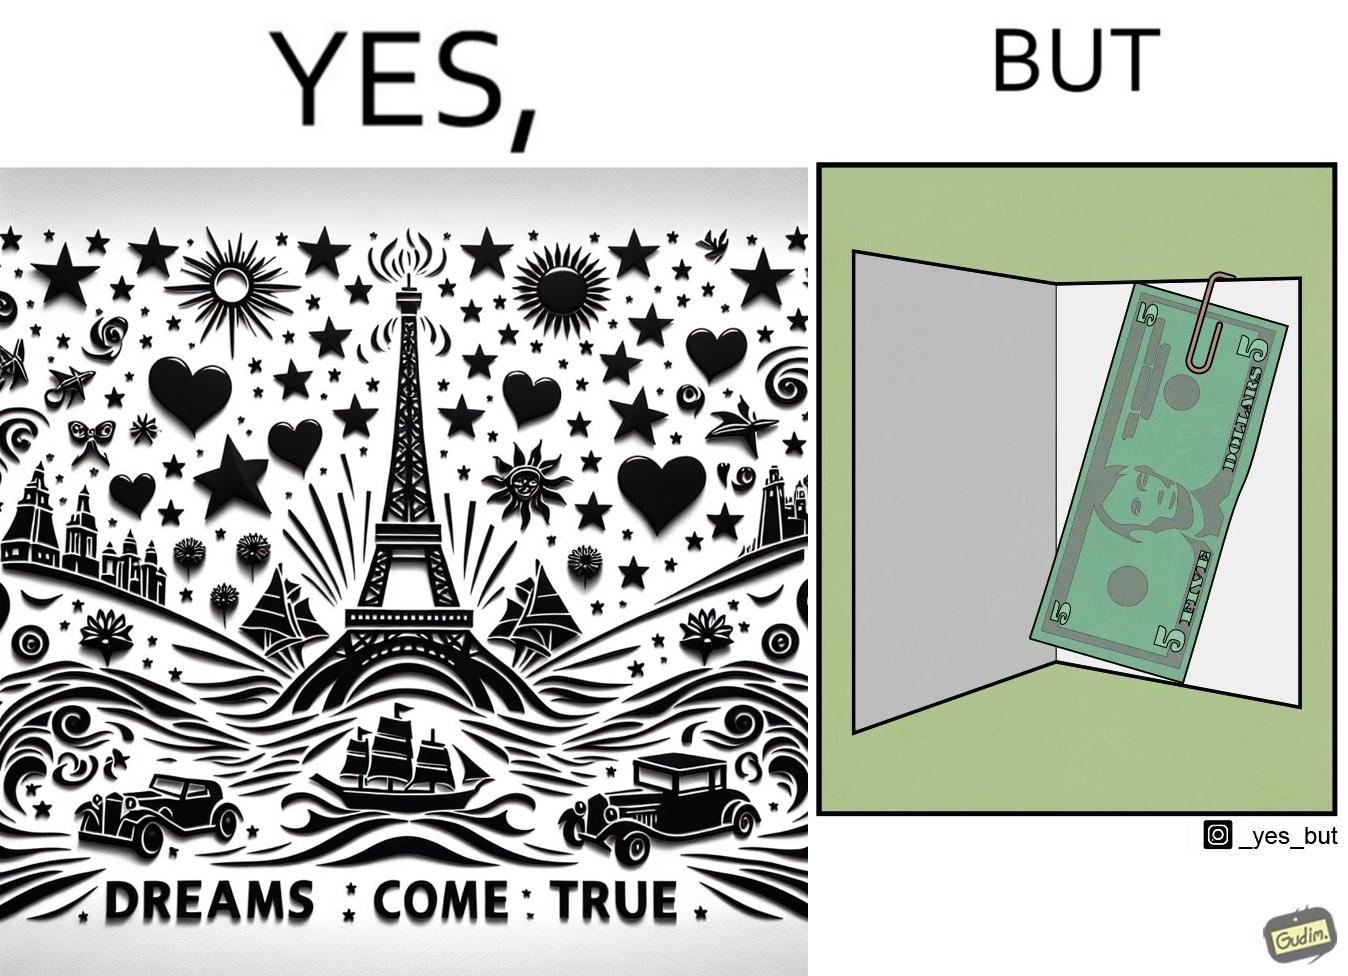What do you see in each half of this image? In the left part of the image: The image shows the front side of a card with the text saying "dreams come true". There are also various drawings of sun, starts, hearts, ships, cars and eiffel tower on the card. In the right part of the image: The image shows a 5 US dollar bill clipped to a card. 